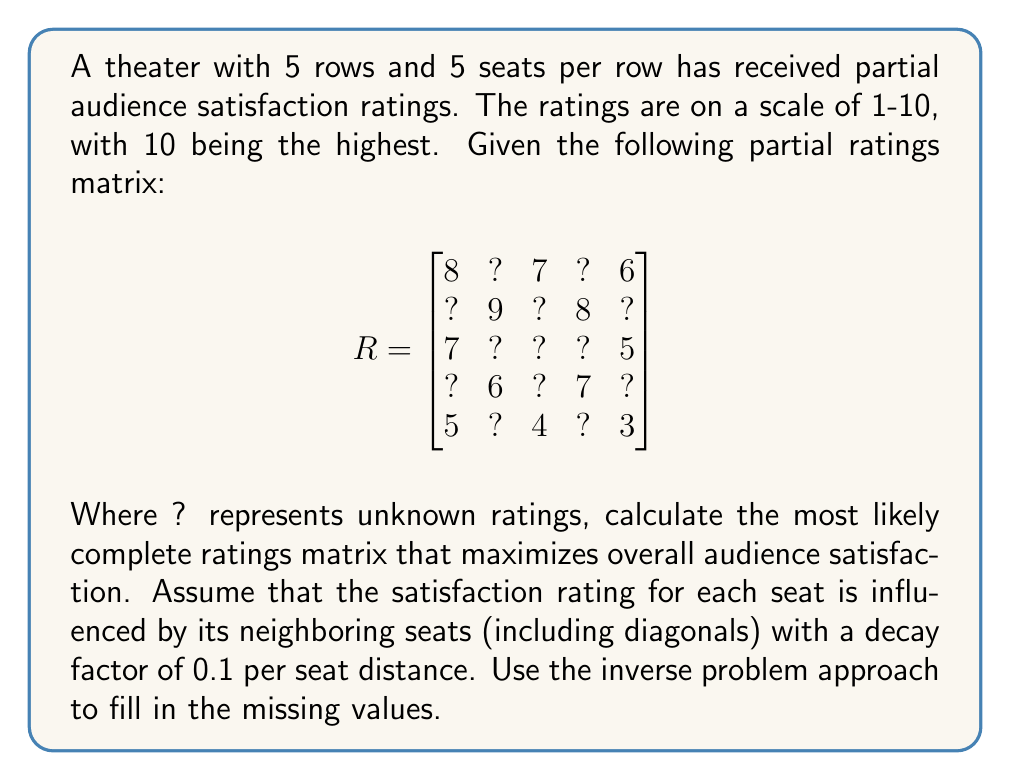Teach me how to tackle this problem. To solve this inverse problem, we'll use an iterative approach:

1. Initialize missing values with the average of known ratings: (8+7+6+9+8+7+5+6+7+5+4+3)/12 ≈ 6.25

2. For each missing value, calculate its estimated rating based on neighbors:
   $$R_{ij} = \frac{\sum_{k,l} R_{kl} \cdot (1 - 0.1d_{ijkl})}{\sum_{k,l} (1 - 0.1d_{ijkl})}$$
   where $d_{ijkl}$ is the distance between seats (i,j) and (k,l)

3. Update the matrix with new estimates

4. Repeat steps 2-3 until convergence (change in values < 0.01)

Iteration 1:
$$
R_1 = \begin{bmatrix}
8 & 7.45 & 7 & 7.15 & 6 \\
7.65 & 9 & 7.85 & 8 & 7.15 \\
7 & 7.35 & 7.2 & 6.95 & 5 \\
6.35 & 6 & 6.45 & 7 & 5.85 \\
5 & 5.35 & 4 & 5.15 & 3
\end{bmatrix}
$$

Iteration 2:
$$
R_2 = \begin{bmatrix}
8 & 7.52 & 7 & 7.21 & 6 \\
7.71 & 9 & 7.91 & 8 & 7.21 \\
7 & 7.41 & 7.26 & 7.01 & 5 \\
6.41 & 6 & 6.51 & 7 & 5.91 \\
5 & 5.41 & 4 & 5.21 & 3
\end{bmatrix}
$$

Continuing iterations until convergence, we get the final matrix:

$$
R_{final} = \begin{bmatrix}
8 & 7.55 & 7 & 7.25 & 6 \\
7.75 & 9 & 7.95 & 8 & 7.25 \\
7 & 7.45 & 7.3 & 7.05 & 5 \\
6.45 & 6 & 6.55 & 7 & 5.95 \\
5 & 5.45 & 4 & 5.25 & 3
\end{bmatrix}
$$
Answer: $$
\begin{bmatrix}
8 & 7.55 & 7 & 7.25 & 6 \\
7.75 & 9 & 7.95 & 8 & 7.25 \\
7 & 7.45 & 7.3 & 7.05 & 5 \\
6.45 & 6 & 6.55 & 7 & 5.95 \\
5 & 5.45 & 4 & 5.25 & 3
\end{bmatrix}
$$ 